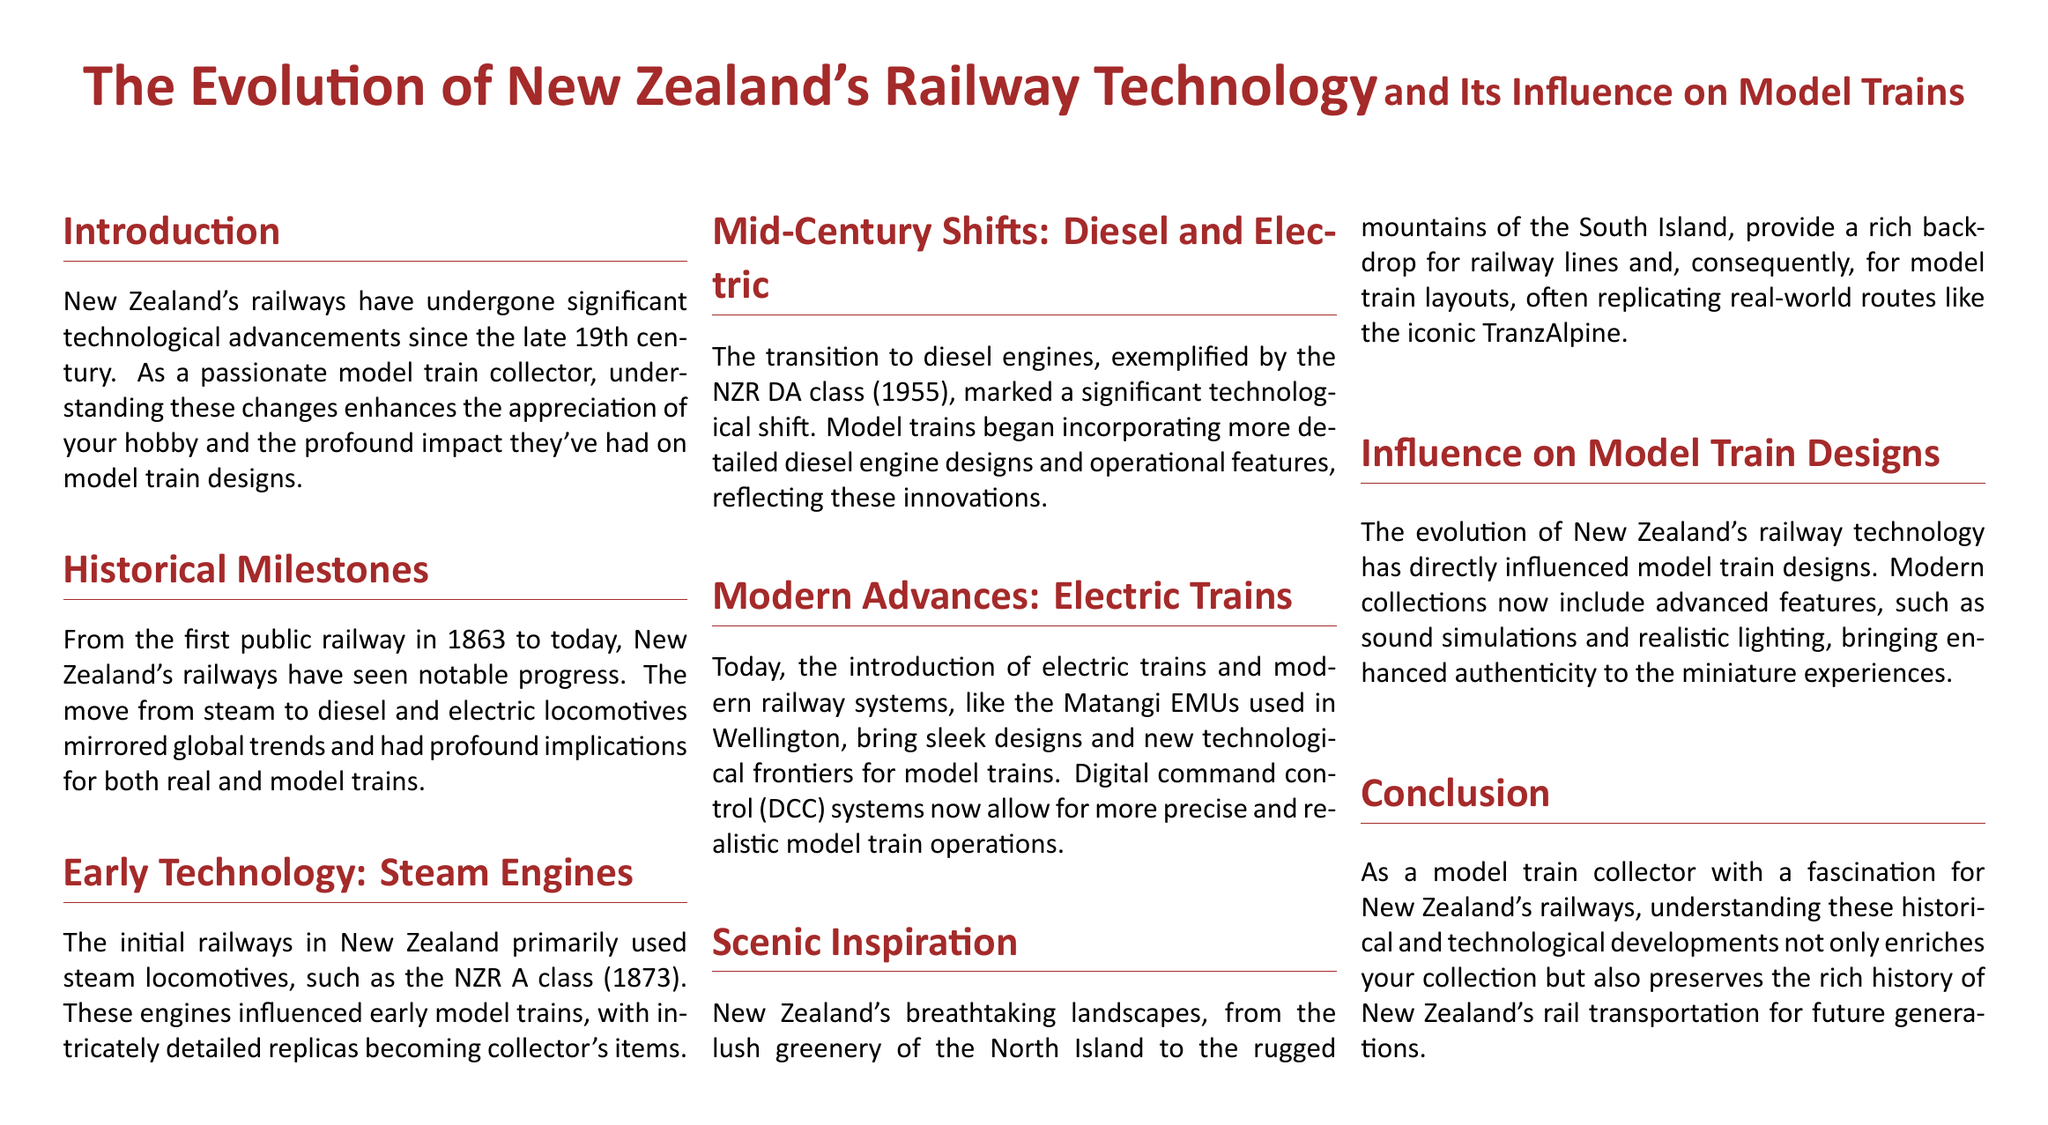What year was the first public railway in New Zealand established? The document states that the first public railway was established in 1863.
Answer: 1863 What class of steam locomotive was mentioned in the document? The document references the NZR A class steam locomotive, which was introduced in 1873.
Answer: NZR A class Which diesel locomotive class is highlighted in the document? The document mentions the NZR DA class diesel locomotive, which was introduced in 1955.
Answer: NZR DA class What modern system is used in Wellington's electric trains? The document refers to the Matangi EMUs as the modern railway system used in Wellington.
Answer: Matangi EMUs How have model train designs evolved according to the document? The document explains that model trains now include advanced features like sound simulations and realistic lighting.
Answer: Advanced features What geographical feature inspires model train layouts in New Zealand? The document highlights New Zealand's breathtaking landscapes as an inspiration for model train layouts.
Answer: Breathtaking landscapes What significant change occurred in railway technology during the mid-century? The document points out the shift from steam engines to diesel and electric locomotives as a significant technological change.
Answer: Shift to diesel and electric What does DCC stand for in the context of model trains? The document indicates that DCC stands for digital command control, which allows for more precise model train operations.
Answer: Digital command control How does understanding railway technology benefit model train collectors? The document states that understanding technological developments enriches the collector's experience and preserves history.
Answer: Enriches experience 